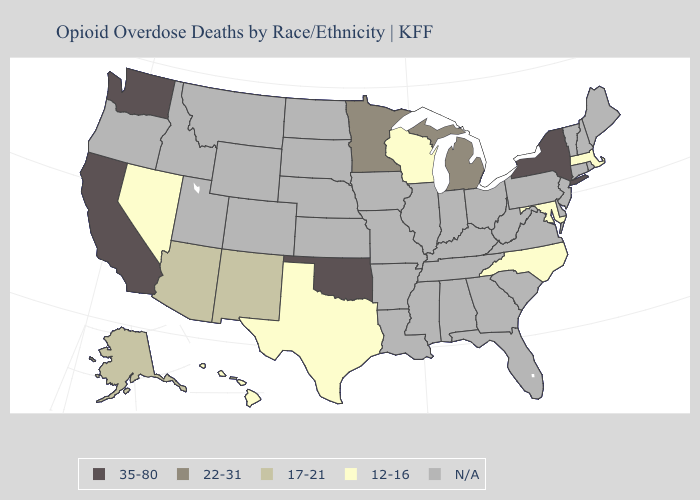Which states have the highest value in the USA?
Quick response, please. California, New York, Oklahoma, Washington. Name the states that have a value in the range 35-80?
Short answer required. California, New York, Oklahoma, Washington. Does Washington have the highest value in the USA?
Concise answer only. Yes. Name the states that have a value in the range 35-80?
Be succinct. California, New York, Oklahoma, Washington. Which states hav the highest value in the MidWest?
Answer briefly. Michigan, Minnesota. How many symbols are there in the legend?
Write a very short answer. 5. Does the map have missing data?
Short answer required. Yes. Does the map have missing data?
Quick response, please. Yes. Which states have the lowest value in the USA?
Quick response, please. Hawaii, Maryland, Massachusetts, Nevada, North Carolina, Texas, Wisconsin. Does the first symbol in the legend represent the smallest category?
Write a very short answer. No. Name the states that have a value in the range 35-80?
Short answer required. California, New York, Oklahoma, Washington. What is the value of Illinois?
Quick response, please. N/A. What is the value of South Dakota?
Concise answer only. N/A. Does North Carolina have the lowest value in the South?
Concise answer only. Yes. 